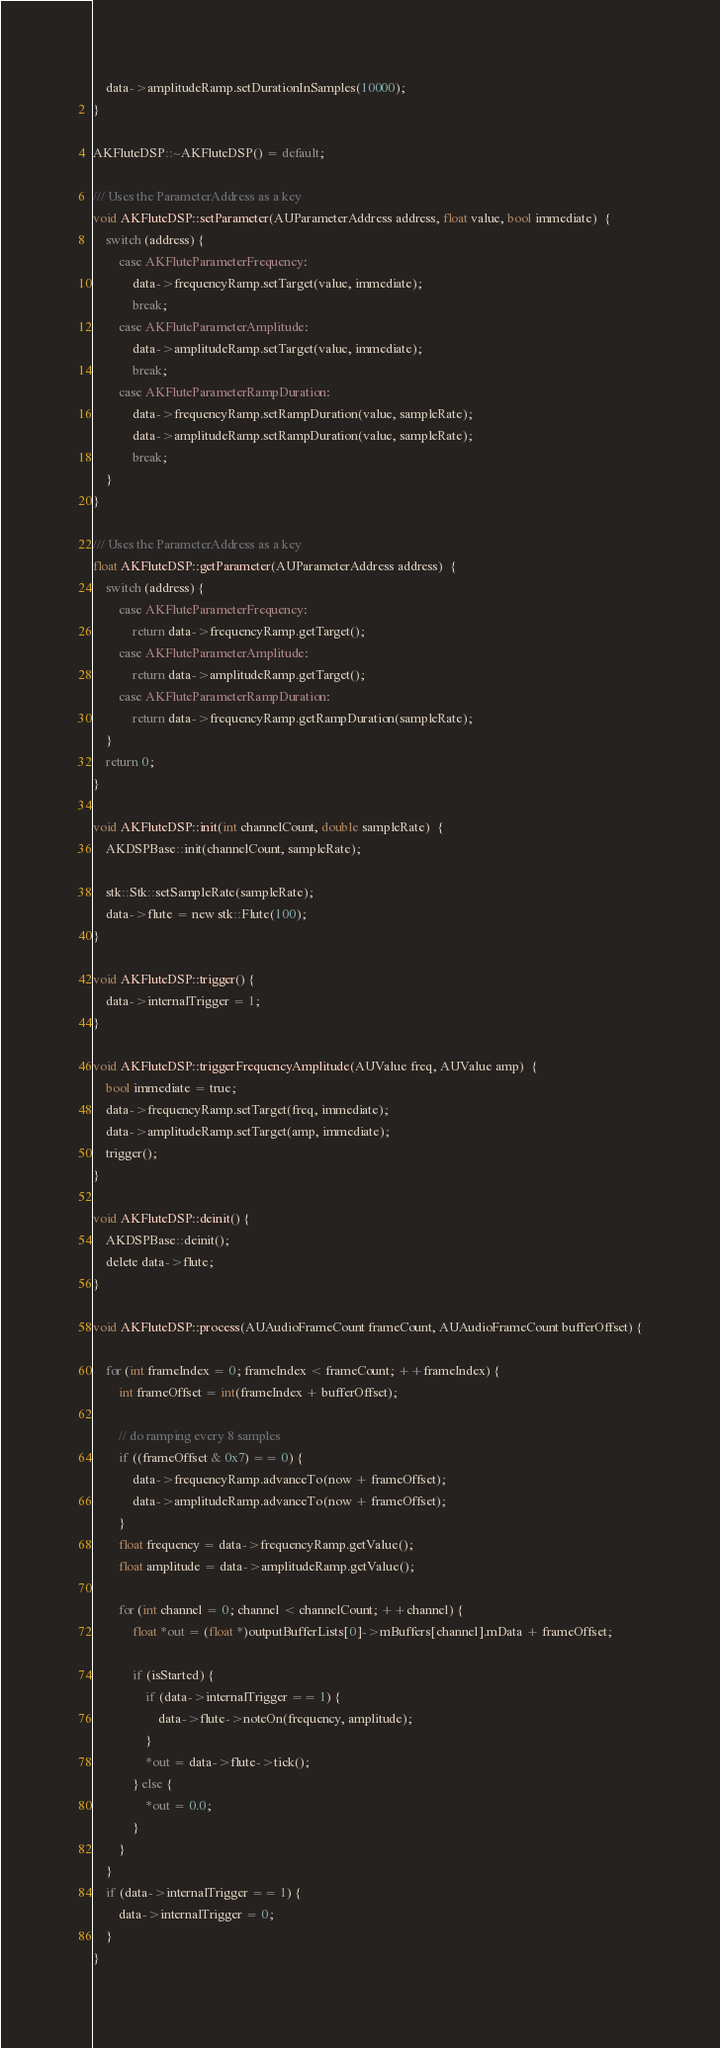<code> <loc_0><loc_0><loc_500><loc_500><_ObjectiveC_>    data->amplitudeRamp.setDurationInSamples(10000);
}

AKFluteDSP::~AKFluteDSP() = default;

/// Uses the ParameterAddress as a key
void AKFluteDSP::setParameter(AUParameterAddress address, float value, bool immediate)  {
    switch (address) {
        case AKFluteParameterFrequency:
            data->frequencyRamp.setTarget(value, immediate);
            break;
        case AKFluteParameterAmplitude:
            data->amplitudeRamp.setTarget(value, immediate);
            break;
        case AKFluteParameterRampDuration:
            data->frequencyRamp.setRampDuration(value, sampleRate);
            data->amplitudeRamp.setRampDuration(value, sampleRate);
            break;
    }
}

/// Uses the ParameterAddress as a key
float AKFluteDSP::getParameter(AUParameterAddress address)  {
    switch (address) {
        case AKFluteParameterFrequency:
            return data->frequencyRamp.getTarget();
        case AKFluteParameterAmplitude:
            return data->amplitudeRamp.getTarget();
        case AKFluteParameterRampDuration:
            return data->frequencyRamp.getRampDuration(sampleRate);
    }
    return 0;
}

void AKFluteDSP::init(int channelCount, double sampleRate)  {
    AKDSPBase::init(channelCount, sampleRate);

    stk::Stk::setSampleRate(sampleRate);
    data->flute = new stk::Flute(100);
}

void AKFluteDSP::trigger() {
    data->internalTrigger = 1;
}

void AKFluteDSP::triggerFrequencyAmplitude(AUValue freq, AUValue amp)  {
    bool immediate = true;
    data->frequencyRamp.setTarget(freq, immediate);
    data->amplitudeRamp.setTarget(amp, immediate);
    trigger();
}

void AKFluteDSP::deinit() {
    AKDSPBase::deinit();
    delete data->flute;
}

void AKFluteDSP::process(AUAudioFrameCount frameCount, AUAudioFrameCount bufferOffset) {

    for (int frameIndex = 0; frameIndex < frameCount; ++frameIndex) {
        int frameOffset = int(frameIndex + bufferOffset);

        // do ramping every 8 samples
        if ((frameOffset & 0x7) == 0) {
            data->frequencyRamp.advanceTo(now + frameOffset);
            data->amplitudeRamp.advanceTo(now + frameOffset);
        }
        float frequency = data->frequencyRamp.getValue();
        float amplitude = data->amplitudeRamp.getValue();

        for (int channel = 0; channel < channelCount; ++channel) {
            float *out = (float *)outputBufferLists[0]->mBuffers[channel].mData + frameOffset;

            if (isStarted) {
                if (data->internalTrigger == 1) {
                    data->flute->noteOn(frequency, amplitude);
                }
                *out = data->flute->tick();
            } else {
                *out = 0.0;
            }
        }
    }
    if (data->internalTrigger == 1) {
        data->internalTrigger = 0;
    }
}

</code> 